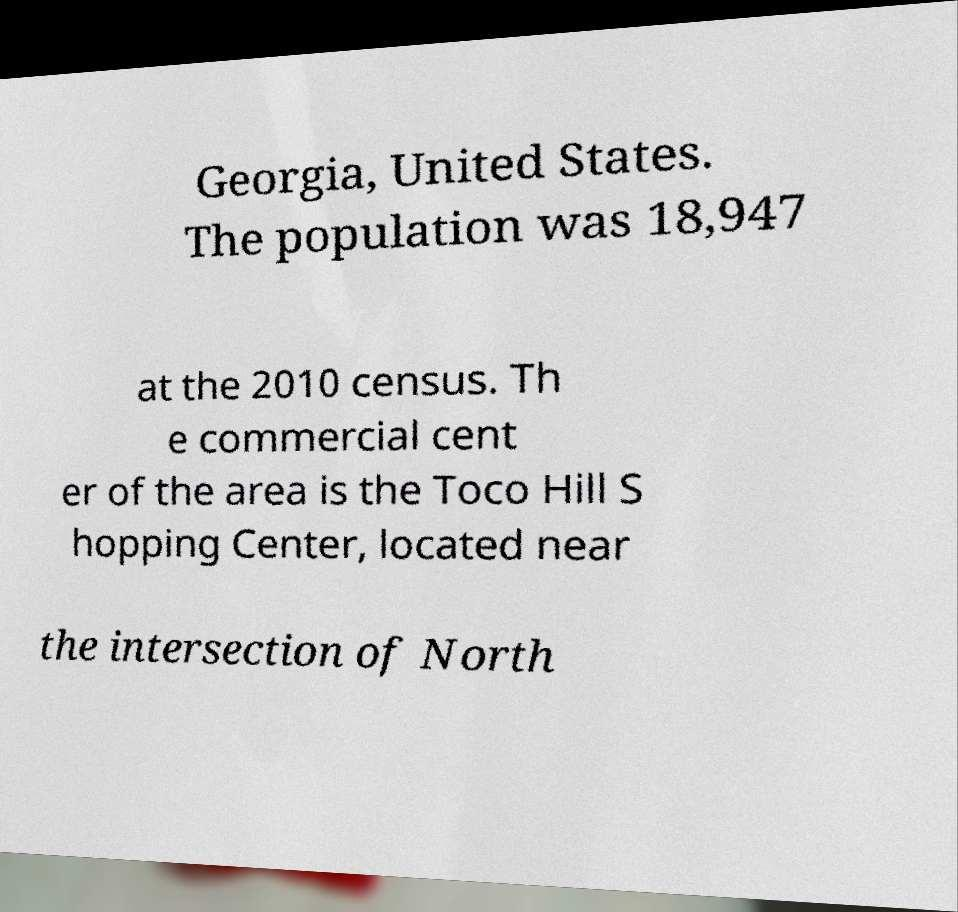For documentation purposes, I need the text within this image transcribed. Could you provide that? Georgia, United States. The population was 18,947 at the 2010 census. Th e commercial cent er of the area is the Toco Hill S hopping Center, located near the intersection of North 